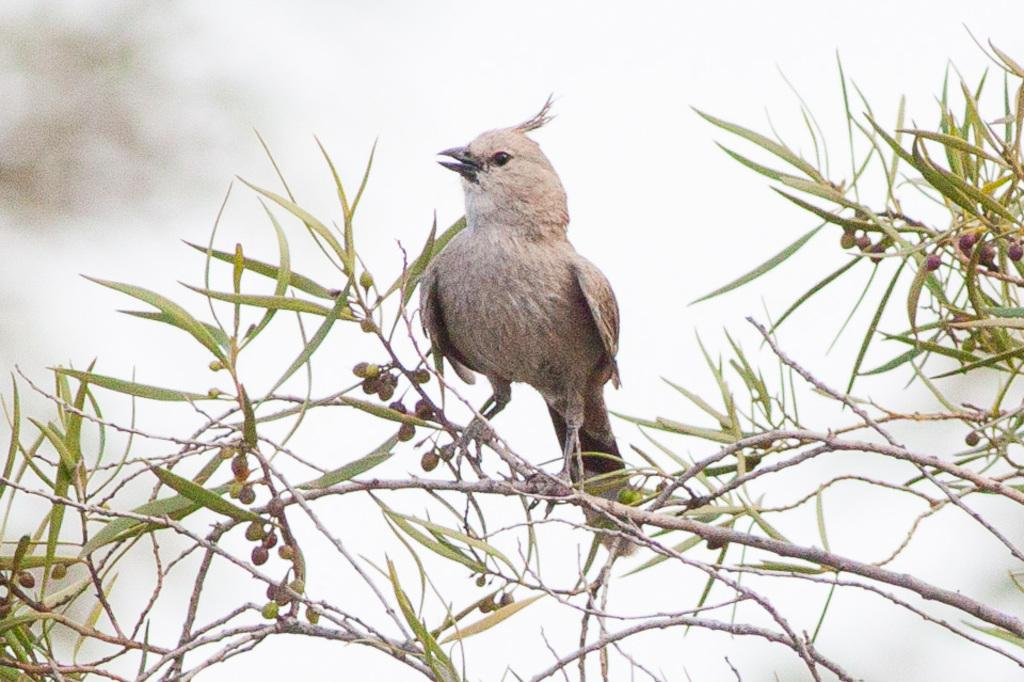What animal can be seen in the image? There is a bird on a tree in the image. Can you describe the background of the image? The background of the image is blurred. What stage of development is the bird in the image? The facts provided do not give any information about the bird's stage of development, so it cannot be determined from the image. What scientific principles are being demonstrated in the image? The image does not depict any scientific principles; it simply shows a bird on a tree. 